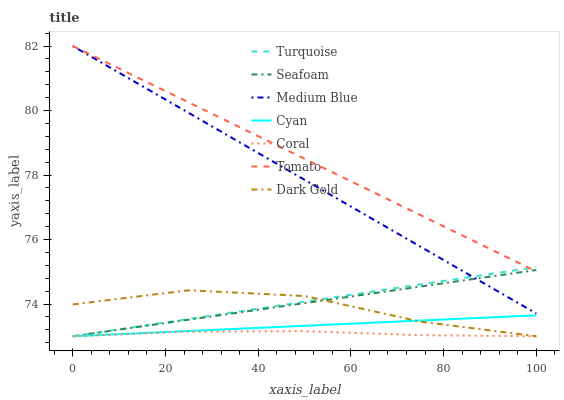Does Coral have the minimum area under the curve?
Answer yes or no. Yes. Does Tomato have the maximum area under the curve?
Answer yes or no. Yes. Does Turquoise have the minimum area under the curve?
Answer yes or no. No. Does Turquoise have the maximum area under the curve?
Answer yes or no. No. Is Turquoise the smoothest?
Answer yes or no. Yes. Is Dark Gold the roughest?
Answer yes or no. Yes. Is Dark Gold the smoothest?
Answer yes or no. No. Is Turquoise the roughest?
Answer yes or no. No. Does Turquoise have the lowest value?
Answer yes or no. Yes. Does Medium Blue have the lowest value?
Answer yes or no. No. Does Medium Blue have the highest value?
Answer yes or no. Yes. Does Turquoise have the highest value?
Answer yes or no. No. Is Cyan less than Medium Blue?
Answer yes or no. Yes. Is Tomato greater than Coral?
Answer yes or no. Yes. Does Medium Blue intersect Tomato?
Answer yes or no. Yes. Is Medium Blue less than Tomato?
Answer yes or no. No. Is Medium Blue greater than Tomato?
Answer yes or no. No. Does Cyan intersect Medium Blue?
Answer yes or no. No. 